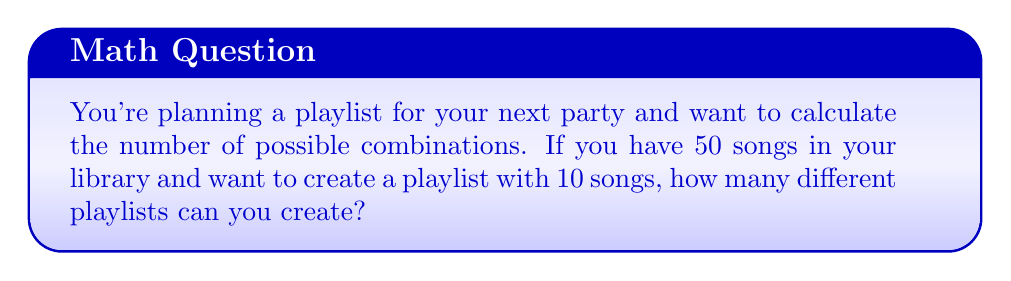Solve this math problem. To solve this problem, we need to use the concept of combinations. We are selecting 10 songs from a total of 50 songs, where the order doesn't matter (since it's a playlist that can be shuffled).

The formula for combinations is:

$$C(n,r) = \frac{n!}{r!(n-r)!}$$

Where:
$n$ is the total number of items to choose from (50 songs)
$r$ is the number of items being chosen (10 songs)

Let's substitute these values:

$$C(50,10) = \frac{50!}{10!(50-10)!} = \frac{50!}{10!40!}$$

To calculate this:

1) First, let's expand this:
   $$\frac{50 \times 49 \times 48 \times 47 \times 46 \times 45 \times 44 \times 43 \times 42 \times 41 \times 40!}{(10 \times 9 \times 8 \times 7 \times 6 \times 5 \times 4 \times 3 \times 2 \times 1) \times 40!}$$

2) The 40! cancels out in the numerator and denominator:
   $$\frac{50 \times 49 \times 48 \times 47 \times 46 \times 45 \times 44 \times 43 \times 42 \times 41}{10 \times 9 \times 8 \times 7 \times 6 \times 5 \times 4 \times 3 \times 2 \times 1}$$

3) Multiply the numerator and denominator:
   $$\frac{10,272,278,170,000}{3,628,800}$$

4) Divide:
   $$2,829,468$$

Therefore, you can create 2,829,468 different playlists.
Answer: 2,829,468 